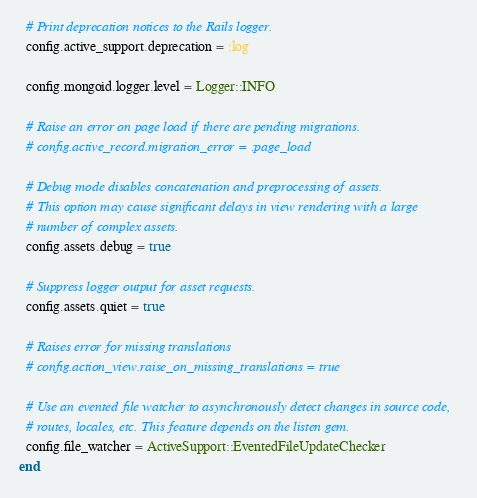<code> <loc_0><loc_0><loc_500><loc_500><_Ruby_>
  # Print deprecation notices to the Rails logger.
  config.active_support.deprecation = :log

  config.mongoid.logger.level = Logger::INFO

  # Raise an error on page load if there are pending migrations.
  # config.active_record.migration_error = :page_load

  # Debug mode disables concatenation and preprocessing of assets.
  # This option may cause significant delays in view rendering with a large
  # number of complex assets.
  config.assets.debug = true

  # Suppress logger output for asset requests.
  config.assets.quiet = true

  # Raises error for missing translations
  # config.action_view.raise_on_missing_translations = true

  # Use an evented file watcher to asynchronously detect changes in source code,
  # routes, locales, etc. This feature depends on the listen gem.
  config.file_watcher = ActiveSupport::EventedFileUpdateChecker
end
</code> 